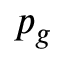Convert formula to latex. <formula><loc_0><loc_0><loc_500><loc_500>p _ { g }</formula> 